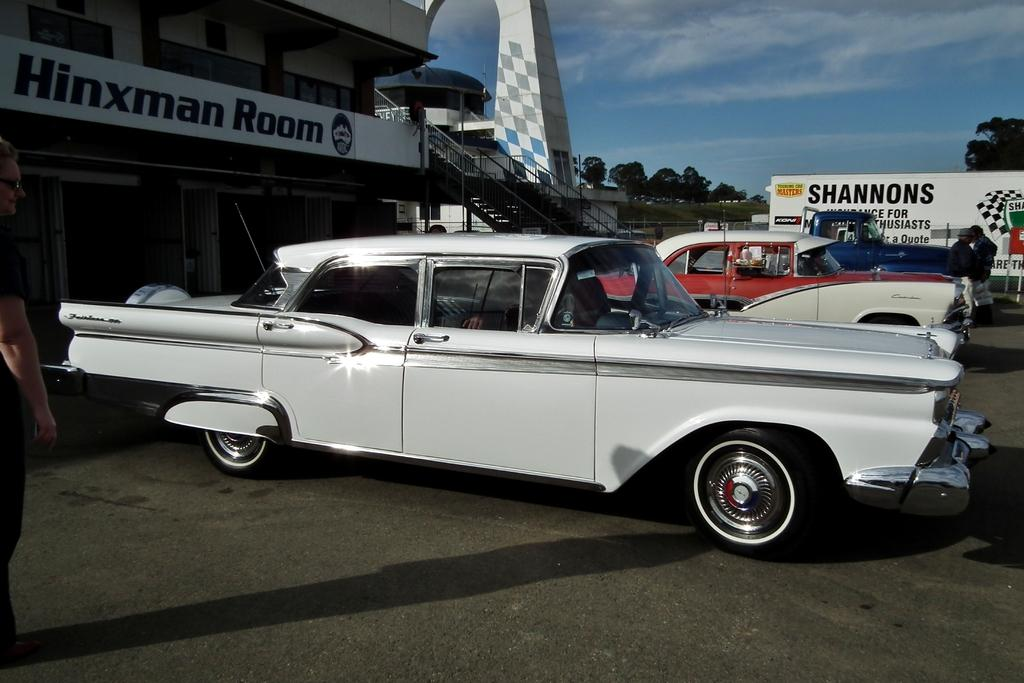What types of objects can be seen in the image? There are vehicles and buildings in the image. Can you describe the people in the image? There is a group of people in the image. What is visible in the background of the image? There is a hoarding, trees, and clouds in the background of the image. What type of coat is the peace symbol wearing in the image? There is no peace symbol or coat present in the image. 